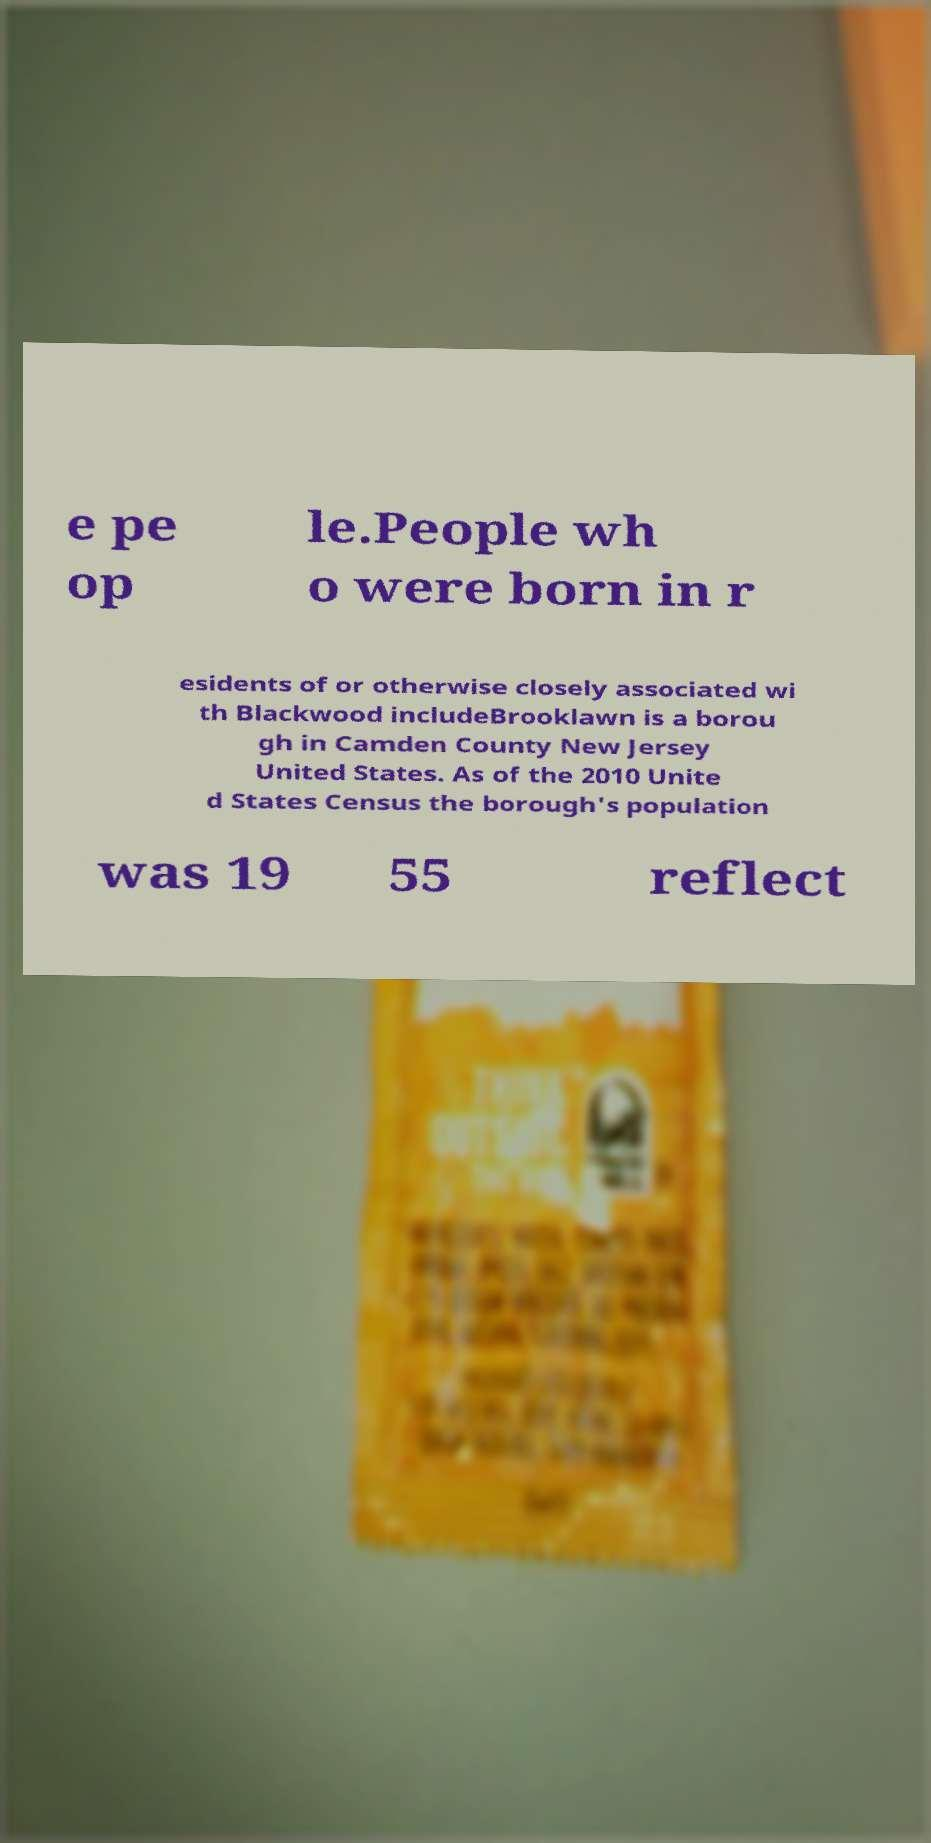Can you read and provide the text displayed in the image?This photo seems to have some interesting text. Can you extract and type it out for me? e pe op le.People wh o were born in r esidents of or otherwise closely associated wi th Blackwood includeBrooklawn is a borou gh in Camden County New Jersey United States. As of the 2010 Unite d States Census the borough's population was 19 55 reflect 